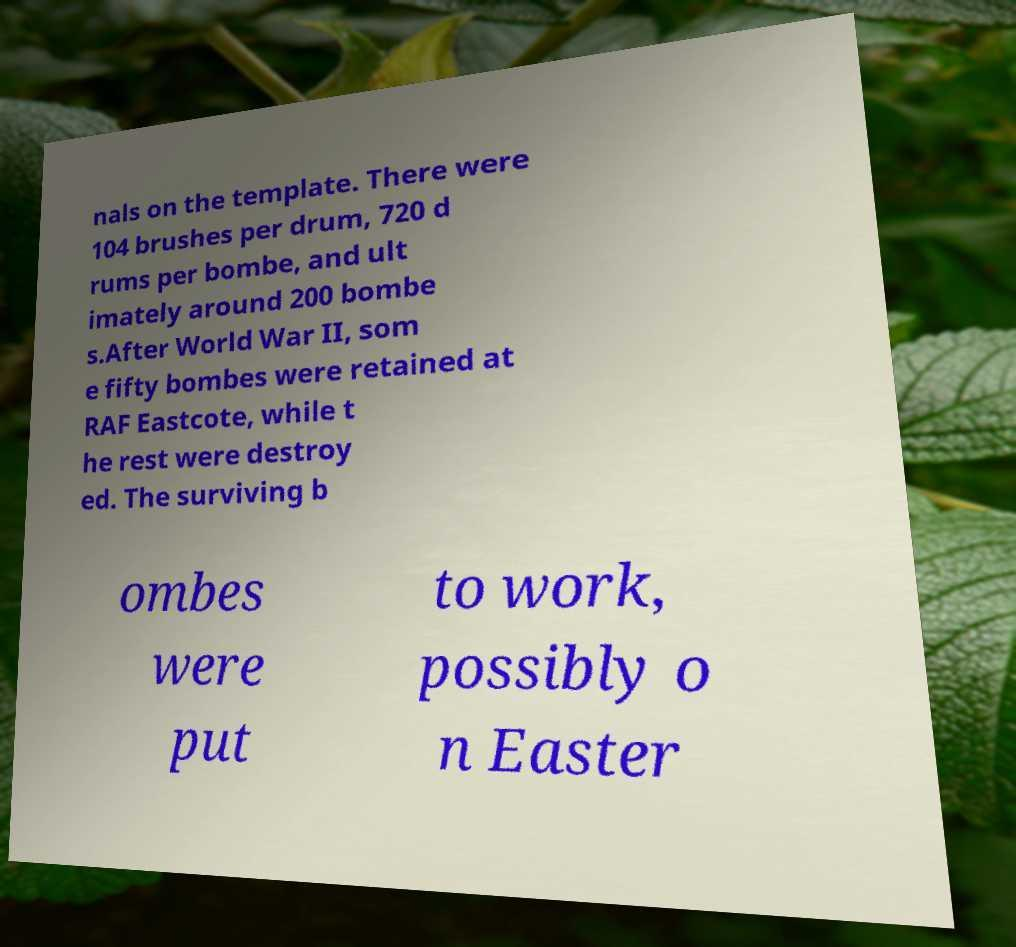Could you assist in decoding the text presented in this image and type it out clearly? nals on the template. There were 104 brushes per drum, 720 d rums per bombe, and ult imately around 200 bombe s.After World War II, som e fifty bombes were retained at RAF Eastcote, while t he rest were destroy ed. The surviving b ombes were put to work, possibly o n Easter 